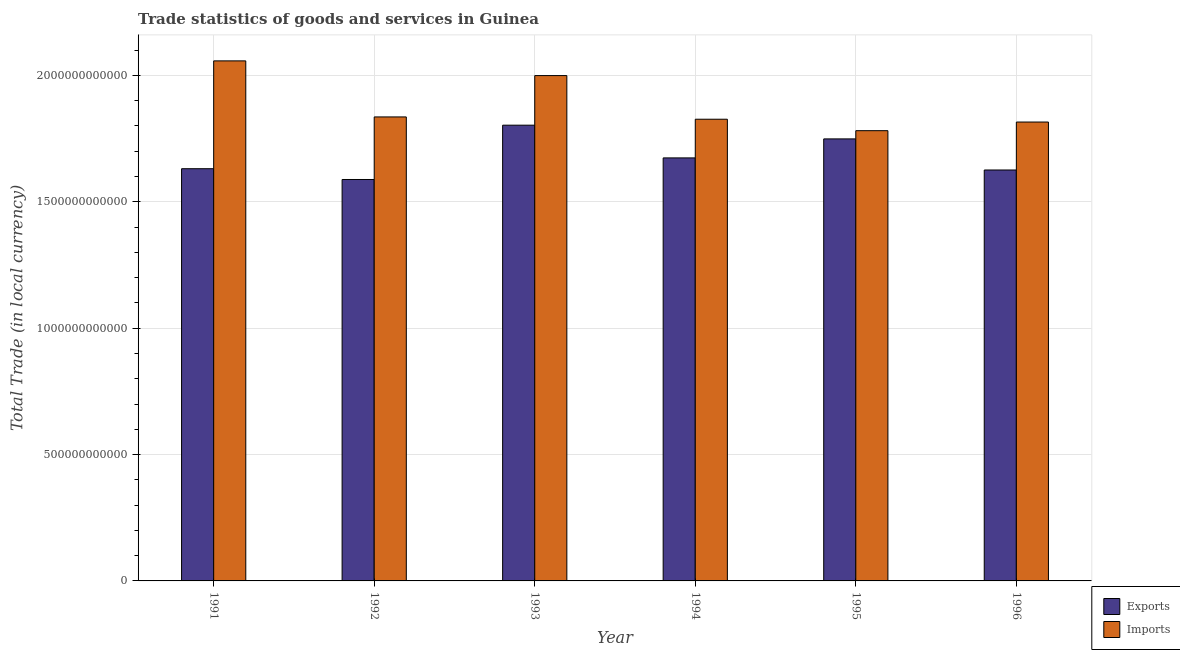Are the number of bars per tick equal to the number of legend labels?
Provide a short and direct response. Yes. How many bars are there on the 3rd tick from the left?
Offer a very short reply. 2. How many bars are there on the 6th tick from the right?
Give a very brief answer. 2. What is the label of the 2nd group of bars from the left?
Ensure brevity in your answer.  1992. What is the export of goods and services in 1991?
Your answer should be compact. 1.63e+12. Across all years, what is the maximum imports of goods and services?
Provide a succinct answer. 2.06e+12. Across all years, what is the minimum imports of goods and services?
Your response must be concise. 1.78e+12. In which year was the export of goods and services minimum?
Make the answer very short. 1992. What is the total imports of goods and services in the graph?
Offer a very short reply. 1.13e+13. What is the difference between the imports of goods and services in 1992 and that in 1995?
Make the answer very short. 5.44e+1. What is the difference between the export of goods and services in 1991 and the imports of goods and services in 1996?
Your response must be concise. 5.09e+09. What is the average export of goods and services per year?
Provide a succinct answer. 1.68e+12. In how many years, is the export of goods and services greater than 2000000000000 LCU?
Your answer should be compact. 0. What is the ratio of the imports of goods and services in 1992 to that in 1993?
Offer a terse response. 0.92. What is the difference between the highest and the second highest imports of goods and services?
Make the answer very short. 5.82e+1. What is the difference between the highest and the lowest imports of goods and services?
Give a very brief answer. 2.76e+11. What does the 2nd bar from the left in 1996 represents?
Provide a succinct answer. Imports. What does the 2nd bar from the right in 1996 represents?
Your response must be concise. Exports. How many years are there in the graph?
Provide a succinct answer. 6. What is the difference between two consecutive major ticks on the Y-axis?
Make the answer very short. 5.00e+11. Are the values on the major ticks of Y-axis written in scientific E-notation?
Offer a very short reply. No. Does the graph contain any zero values?
Offer a very short reply. No. Does the graph contain grids?
Make the answer very short. Yes. Where does the legend appear in the graph?
Offer a terse response. Bottom right. How many legend labels are there?
Your answer should be very brief. 2. How are the legend labels stacked?
Keep it short and to the point. Vertical. What is the title of the graph?
Your answer should be compact. Trade statistics of goods and services in Guinea. Does "Register a business" appear as one of the legend labels in the graph?
Your answer should be compact. No. What is the label or title of the Y-axis?
Your response must be concise. Total Trade (in local currency). What is the Total Trade (in local currency) in Exports in 1991?
Ensure brevity in your answer.  1.63e+12. What is the Total Trade (in local currency) of Imports in 1991?
Keep it short and to the point. 2.06e+12. What is the Total Trade (in local currency) of Exports in 1992?
Offer a terse response. 1.59e+12. What is the Total Trade (in local currency) in Imports in 1992?
Make the answer very short. 1.84e+12. What is the Total Trade (in local currency) in Exports in 1993?
Make the answer very short. 1.80e+12. What is the Total Trade (in local currency) of Imports in 1993?
Ensure brevity in your answer.  2.00e+12. What is the Total Trade (in local currency) of Exports in 1994?
Offer a terse response. 1.67e+12. What is the Total Trade (in local currency) in Imports in 1994?
Offer a very short reply. 1.83e+12. What is the Total Trade (in local currency) in Exports in 1995?
Your answer should be very brief. 1.75e+12. What is the Total Trade (in local currency) in Imports in 1995?
Provide a succinct answer. 1.78e+12. What is the Total Trade (in local currency) of Exports in 1996?
Offer a terse response. 1.63e+12. What is the Total Trade (in local currency) of Imports in 1996?
Provide a short and direct response. 1.82e+12. Across all years, what is the maximum Total Trade (in local currency) in Exports?
Ensure brevity in your answer.  1.80e+12. Across all years, what is the maximum Total Trade (in local currency) of Imports?
Give a very brief answer. 2.06e+12. Across all years, what is the minimum Total Trade (in local currency) of Exports?
Provide a short and direct response. 1.59e+12. Across all years, what is the minimum Total Trade (in local currency) in Imports?
Provide a short and direct response. 1.78e+12. What is the total Total Trade (in local currency) of Exports in the graph?
Your answer should be compact. 1.01e+13. What is the total Total Trade (in local currency) of Imports in the graph?
Offer a very short reply. 1.13e+13. What is the difference between the Total Trade (in local currency) in Exports in 1991 and that in 1992?
Make the answer very short. 4.27e+1. What is the difference between the Total Trade (in local currency) of Imports in 1991 and that in 1992?
Offer a terse response. 2.22e+11. What is the difference between the Total Trade (in local currency) of Exports in 1991 and that in 1993?
Offer a terse response. -1.72e+11. What is the difference between the Total Trade (in local currency) in Imports in 1991 and that in 1993?
Ensure brevity in your answer.  5.82e+1. What is the difference between the Total Trade (in local currency) in Exports in 1991 and that in 1994?
Offer a terse response. -4.27e+1. What is the difference between the Total Trade (in local currency) of Imports in 1991 and that in 1994?
Give a very brief answer. 2.31e+11. What is the difference between the Total Trade (in local currency) in Exports in 1991 and that in 1995?
Your answer should be very brief. -1.18e+11. What is the difference between the Total Trade (in local currency) in Imports in 1991 and that in 1995?
Give a very brief answer. 2.76e+11. What is the difference between the Total Trade (in local currency) in Exports in 1991 and that in 1996?
Ensure brevity in your answer.  5.09e+09. What is the difference between the Total Trade (in local currency) in Imports in 1991 and that in 1996?
Provide a succinct answer. 2.42e+11. What is the difference between the Total Trade (in local currency) in Exports in 1992 and that in 1993?
Make the answer very short. -2.15e+11. What is the difference between the Total Trade (in local currency) in Imports in 1992 and that in 1993?
Provide a succinct answer. -1.64e+11. What is the difference between the Total Trade (in local currency) of Exports in 1992 and that in 1994?
Ensure brevity in your answer.  -8.54e+1. What is the difference between the Total Trade (in local currency) in Imports in 1992 and that in 1994?
Keep it short and to the point. 9.11e+09. What is the difference between the Total Trade (in local currency) of Exports in 1992 and that in 1995?
Ensure brevity in your answer.  -1.61e+11. What is the difference between the Total Trade (in local currency) in Imports in 1992 and that in 1995?
Provide a short and direct response. 5.44e+1. What is the difference between the Total Trade (in local currency) of Exports in 1992 and that in 1996?
Offer a terse response. -3.76e+1. What is the difference between the Total Trade (in local currency) of Imports in 1992 and that in 1996?
Give a very brief answer. 2.02e+1. What is the difference between the Total Trade (in local currency) in Exports in 1993 and that in 1994?
Provide a short and direct response. 1.29e+11. What is the difference between the Total Trade (in local currency) of Imports in 1993 and that in 1994?
Keep it short and to the point. 1.73e+11. What is the difference between the Total Trade (in local currency) in Exports in 1993 and that in 1995?
Your answer should be very brief. 5.43e+1. What is the difference between the Total Trade (in local currency) of Imports in 1993 and that in 1995?
Your answer should be very brief. 2.18e+11. What is the difference between the Total Trade (in local currency) in Exports in 1993 and that in 1996?
Provide a succinct answer. 1.77e+11. What is the difference between the Total Trade (in local currency) in Imports in 1993 and that in 1996?
Ensure brevity in your answer.  1.84e+11. What is the difference between the Total Trade (in local currency) in Exports in 1994 and that in 1995?
Provide a short and direct response. -7.52e+1. What is the difference between the Total Trade (in local currency) of Imports in 1994 and that in 1995?
Provide a short and direct response. 4.53e+1. What is the difference between the Total Trade (in local currency) of Exports in 1994 and that in 1996?
Provide a succinct answer. 4.78e+1. What is the difference between the Total Trade (in local currency) in Imports in 1994 and that in 1996?
Offer a very short reply. 1.11e+1. What is the difference between the Total Trade (in local currency) of Exports in 1995 and that in 1996?
Make the answer very short. 1.23e+11. What is the difference between the Total Trade (in local currency) in Imports in 1995 and that in 1996?
Provide a short and direct response. -3.42e+1. What is the difference between the Total Trade (in local currency) of Exports in 1991 and the Total Trade (in local currency) of Imports in 1992?
Provide a short and direct response. -2.05e+11. What is the difference between the Total Trade (in local currency) in Exports in 1991 and the Total Trade (in local currency) in Imports in 1993?
Keep it short and to the point. -3.68e+11. What is the difference between the Total Trade (in local currency) in Exports in 1991 and the Total Trade (in local currency) in Imports in 1994?
Your answer should be compact. -1.96e+11. What is the difference between the Total Trade (in local currency) of Exports in 1991 and the Total Trade (in local currency) of Imports in 1995?
Give a very brief answer. -1.50e+11. What is the difference between the Total Trade (in local currency) of Exports in 1991 and the Total Trade (in local currency) of Imports in 1996?
Make the answer very short. -1.85e+11. What is the difference between the Total Trade (in local currency) in Exports in 1992 and the Total Trade (in local currency) in Imports in 1993?
Offer a terse response. -4.11e+11. What is the difference between the Total Trade (in local currency) in Exports in 1992 and the Total Trade (in local currency) in Imports in 1994?
Make the answer very short. -2.38e+11. What is the difference between the Total Trade (in local currency) in Exports in 1992 and the Total Trade (in local currency) in Imports in 1995?
Your response must be concise. -1.93e+11. What is the difference between the Total Trade (in local currency) of Exports in 1992 and the Total Trade (in local currency) of Imports in 1996?
Keep it short and to the point. -2.27e+11. What is the difference between the Total Trade (in local currency) of Exports in 1993 and the Total Trade (in local currency) of Imports in 1994?
Your answer should be very brief. -2.35e+1. What is the difference between the Total Trade (in local currency) in Exports in 1993 and the Total Trade (in local currency) in Imports in 1995?
Provide a short and direct response. 2.18e+1. What is the difference between the Total Trade (in local currency) of Exports in 1993 and the Total Trade (in local currency) of Imports in 1996?
Give a very brief answer. -1.25e+1. What is the difference between the Total Trade (in local currency) in Exports in 1994 and the Total Trade (in local currency) in Imports in 1995?
Offer a terse response. -1.08e+11. What is the difference between the Total Trade (in local currency) of Exports in 1994 and the Total Trade (in local currency) of Imports in 1996?
Offer a very short reply. -1.42e+11. What is the difference between the Total Trade (in local currency) of Exports in 1995 and the Total Trade (in local currency) of Imports in 1996?
Your answer should be very brief. -6.67e+1. What is the average Total Trade (in local currency) of Exports per year?
Ensure brevity in your answer.  1.68e+12. What is the average Total Trade (in local currency) of Imports per year?
Give a very brief answer. 1.89e+12. In the year 1991, what is the difference between the Total Trade (in local currency) in Exports and Total Trade (in local currency) in Imports?
Offer a very short reply. -4.27e+11. In the year 1992, what is the difference between the Total Trade (in local currency) in Exports and Total Trade (in local currency) in Imports?
Offer a terse response. -2.48e+11. In the year 1993, what is the difference between the Total Trade (in local currency) in Exports and Total Trade (in local currency) in Imports?
Your answer should be compact. -1.96e+11. In the year 1994, what is the difference between the Total Trade (in local currency) of Exports and Total Trade (in local currency) of Imports?
Provide a succinct answer. -1.53e+11. In the year 1995, what is the difference between the Total Trade (in local currency) in Exports and Total Trade (in local currency) in Imports?
Provide a succinct answer. -3.25e+1. In the year 1996, what is the difference between the Total Trade (in local currency) of Exports and Total Trade (in local currency) of Imports?
Ensure brevity in your answer.  -1.90e+11. What is the ratio of the Total Trade (in local currency) in Exports in 1991 to that in 1992?
Offer a terse response. 1.03. What is the ratio of the Total Trade (in local currency) of Imports in 1991 to that in 1992?
Make the answer very short. 1.12. What is the ratio of the Total Trade (in local currency) in Exports in 1991 to that in 1993?
Keep it short and to the point. 0.9. What is the ratio of the Total Trade (in local currency) of Imports in 1991 to that in 1993?
Offer a terse response. 1.03. What is the ratio of the Total Trade (in local currency) in Exports in 1991 to that in 1994?
Provide a short and direct response. 0.97. What is the ratio of the Total Trade (in local currency) in Imports in 1991 to that in 1994?
Offer a very short reply. 1.13. What is the ratio of the Total Trade (in local currency) in Exports in 1991 to that in 1995?
Your answer should be very brief. 0.93. What is the ratio of the Total Trade (in local currency) of Imports in 1991 to that in 1995?
Make the answer very short. 1.16. What is the ratio of the Total Trade (in local currency) of Imports in 1991 to that in 1996?
Your answer should be very brief. 1.13. What is the ratio of the Total Trade (in local currency) in Exports in 1992 to that in 1993?
Your response must be concise. 0.88. What is the ratio of the Total Trade (in local currency) of Imports in 1992 to that in 1993?
Your answer should be very brief. 0.92. What is the ratio of the Total Trade (in local currency) in Exports in 1992 to that in 1994?
Offer a terse response. 0.95. What is the ratio of the Total Trade (in local currency) of Imports in 1992 to that in 1994?
Offer a terse response. 1. What is the ratio of the Total Trade (in local currency) of Exports in 1992 to that in 1995?
Your answer should be very brief. 0.91. What is the ratio of the Total Trade (in local currency) of Imports in 1992 to that in 1995?
Offer a very short reply. 1.03. What is the ratio of the Total Trade (in local currency) in Exports in 1992 to that in 1996?
Your answer should be compact. 0.98. What is the ratio of the Total Trade (in local currency) of Imports in 1992 to that in 1996?
Your answer should be very brief. 1.01. What is the ratio of the Total Trade (in local currency) in Exports in 1993 to that in 1994?
Your answer should be very brief. 1.08. What is the ratio of the Total Trade (in local currency) in Imports in 1993 to that in 1994?
Give a very brief answer. 1.09. What is the ratio of the Total Trade (in local currency) of Exports in 1993 to that in 1995?
Your answer should be very brief. 1.03. What is the ratio of the Total Trade (in local currency) in Imports in 1993 to that in 1995?
Provide a short and direct response. 1.12. What is the ratio of the Total Trade (in local currency) of Exports in 1993 to that in 1996?
Offer a terse response. 1.11. What is the ratio of the Total Trade (in local currency) of Imports in 1993 to that in 1996?
Your answer should be compact. 1.1. What is the ratio of the Total Trade (in local currency) in Imports in 1994 to that in 1995?
Make the answer very short. 1.03. What is the ratio of the Total Trade (in local currency) of Exports in 1994 to that in 1996?
Provide a short and direct response. 1.03. What is the ratio of the Total Trade (in local currency) of Exports in 1995 to that in 1996?
Give a very brief answer. 1.08. What is the ratio of the Total Trade (in local currency) of Imports in 1995 to that in 1996?
Provide a short and direct response. 0.98. What is the difference between the highest and the second highest Total Trade (in local currency) in Exports?
Offer a very short reply. 5.43e+1. What is the difference between the highest and the second highest Total Trade (in local currency) in Imports?
Provide a succinct answer. 5.82e+1. What is the difference between the highest and the lowest Total Trade (in local currency) in Exports?
Make the answer very short. 2.15e+11. What is the difference between the highest and the lowest Total Trade (in local currency) in Imports?
Your answer should be compact. 2.76e+11. 